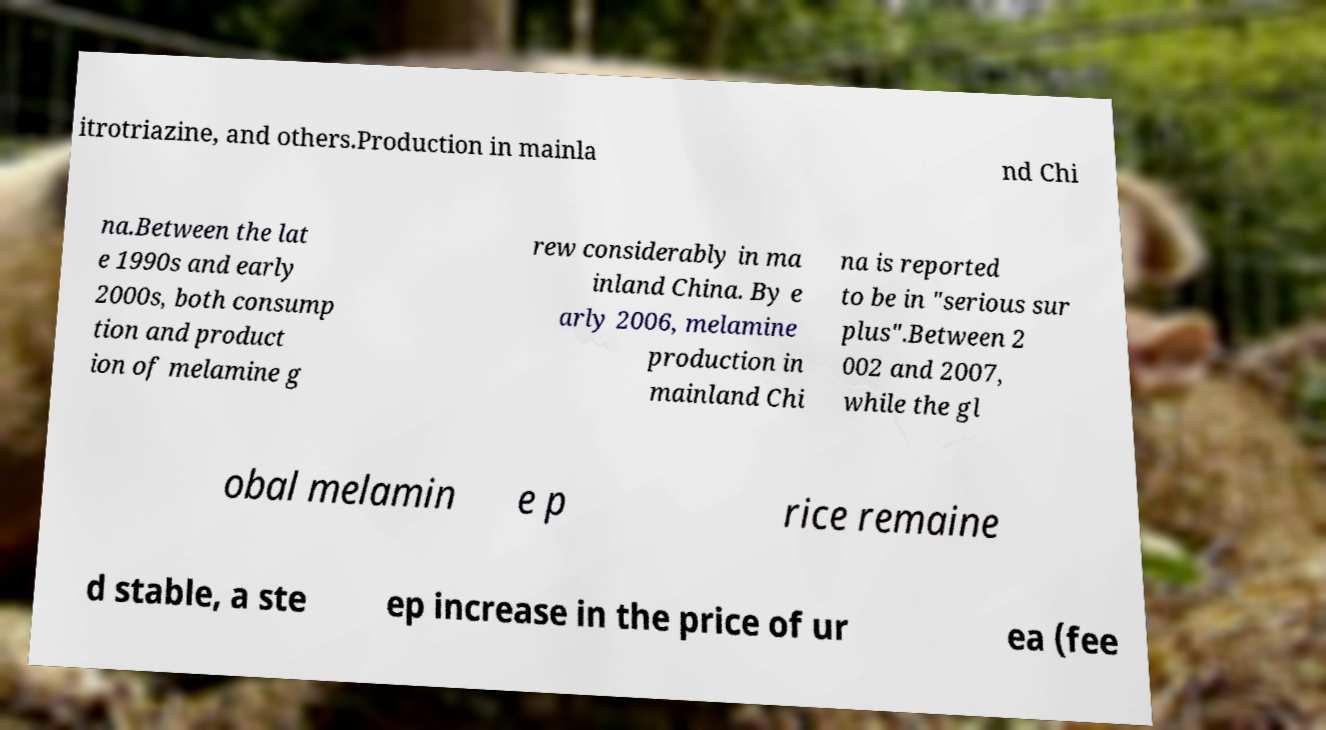Please identify and transcribe the text found in this image. itrotriazine, and others.Production in mainla nd Chi na.Between the lat e 1990s and early 2000s, both consump tion and product ion of melamine g rew considerably in ma inland China. By e arly 2006, melamine production in mainland Chi na is reported to be in "serious sur plus".Between 2 002 and 2007, while the gl obal melamin e p rice remaine d stable, a ste ep increase in the price of ur ea (fee 